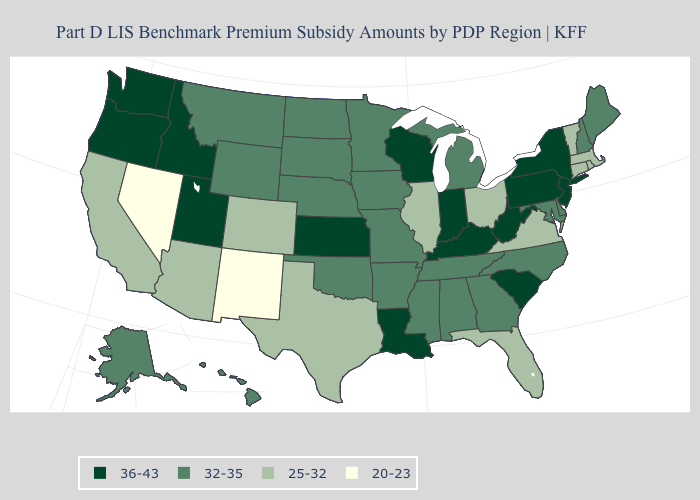Name the states that have a value in the range 20-23?
Keep it brief. Nevada, New Mexico. Among the states that border Oklahoma , does New Mexico have the lowest value?
Write a very short answer. Yes. Does the map have missing data?
Write a very short answer. No. Name the states that have a value in the range 25-32?
Be succinct. Arizona, California, Colorado, Connecticut, Florida, Illinois, Massachusetts, Ohio, Rhode Island, Texas, Vermont, Virginia. What is the highest value in states that border South Carolina?
Answer briefly. 32-35. Among the states that border Nevada , does Utah have the highest value?
Write a very short answer. Yes. What is the value of Ohio?
Answer briefly. 25-32. Does North Carolina have the lowest value in the South?
Short answer required. No. What is the value of Colorado?
Quick response, please. 25-32. What is the highest value in the West ?
Short answer required. 36-43. Name the states that have a value in the range 20-23?
Quick response, please. Nevada, New Mexico. Name the states that have a value in the range 25-32?
Give a very brief answer. Arizona, California, Colorado, Connecticut, Florida, Illinois, Massachusetts, Ohio, Rhode Island, Texas, Vermont, Virginia. What is the lowest value in the USA?
Be succinct. 20-23. Among the states that border West Virginia , does Maryland have the lowest value?
Short answer required. No. What is the highest value in the Northeast ?
Quick response, please. 36-43. 